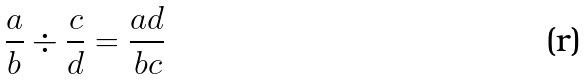Convert formula to latex. <formula><loc_0><loc_0><loc_500><loc_500>\frac { a } { b } \div \frac { c } { d } = \frac { a d } { b c }</formula> 